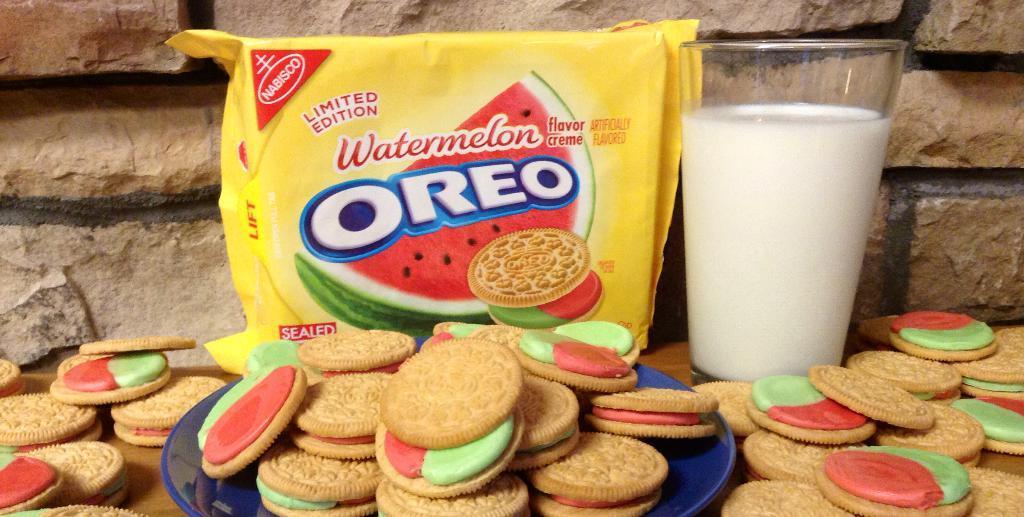Describe this image in one or two sentences. In this picture I can see the Oreo biscuits and package on the table, beside that I can see the milk glass. At the bottom I can see some biscuits in a blue color plates. This table is placed near to the wall. 